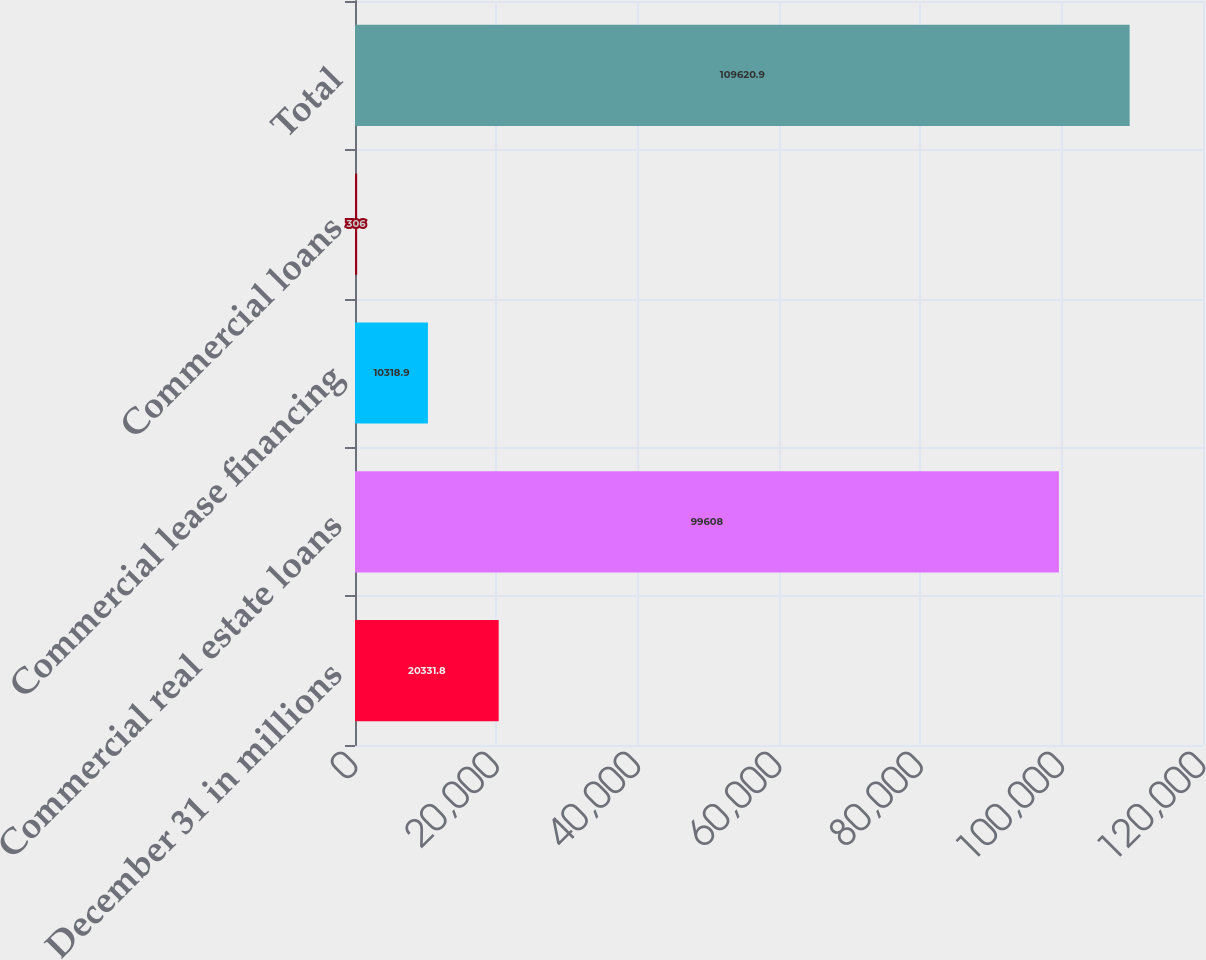Convert chart. <chart><loc_0><loc_0><loc_500><loc_500><bar_chart><fcel>December 31 in millions<fcel>Commercial real estate loans<fcel>Commercial lease financing<fcel>Commercial loans<fcel>Total<nl><fcel>20331.8<fcel>99608<fcel>10318.9<fcel>306<fcel>109621<nl></chart> 